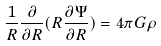<formula> <loc_0><loc_0><loc_500><loc_500>\frac { 1 } { R } \frac { \partial } { \partial R } ( R \frac { \partial \Psi } { \partial R } ) = 4 \pi G \rho</formula> 